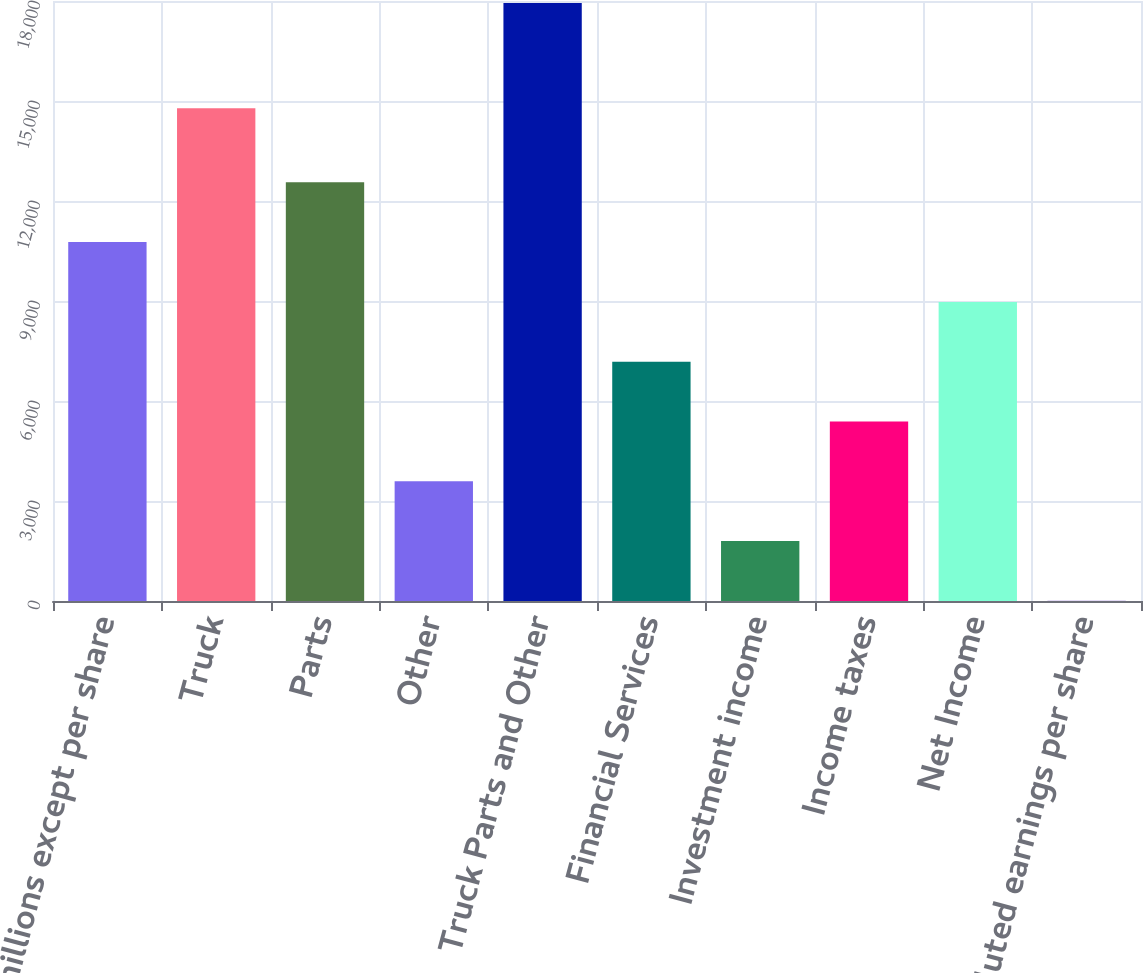<chart> <loc_0><loc_0><loc_500><loc_500><bar_chart><fcel>( in millions except per share<fcel>Truck<fcel>Parts<fcel>Other<fcel>Truck Parts and Other<fcel>Financial Services<fcel>Investment income<fcel>Income taxes<fcel>Net Income<fcel>Diluted earnings per share<nl><fcel>10767.5<fcel>14782.5<fcel>12561.3<fcel>3592.17<fcel>17942.8<fcel>7179.83<fcel>1798.34<fcel>5386<fcel>8973.66<fcel>4.51<nl></chart> 